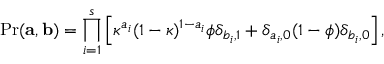<formula> <loc_0><loc_0><loc_500><loc_500>P r ( a , b ) = \prod _ { i = 1 } ^ { s } \left [ \kappa ^ { a _ { i } } ( 1 - \kappa ) ^ { 1 - a _ { i } } \phi \delta _ { b _ { i } , 1 } + \delta _ { a _ { i } , 0 } ( 1 - \phi ) \delta _ { b _ { i } , 0 } \right ] ,</formula> 